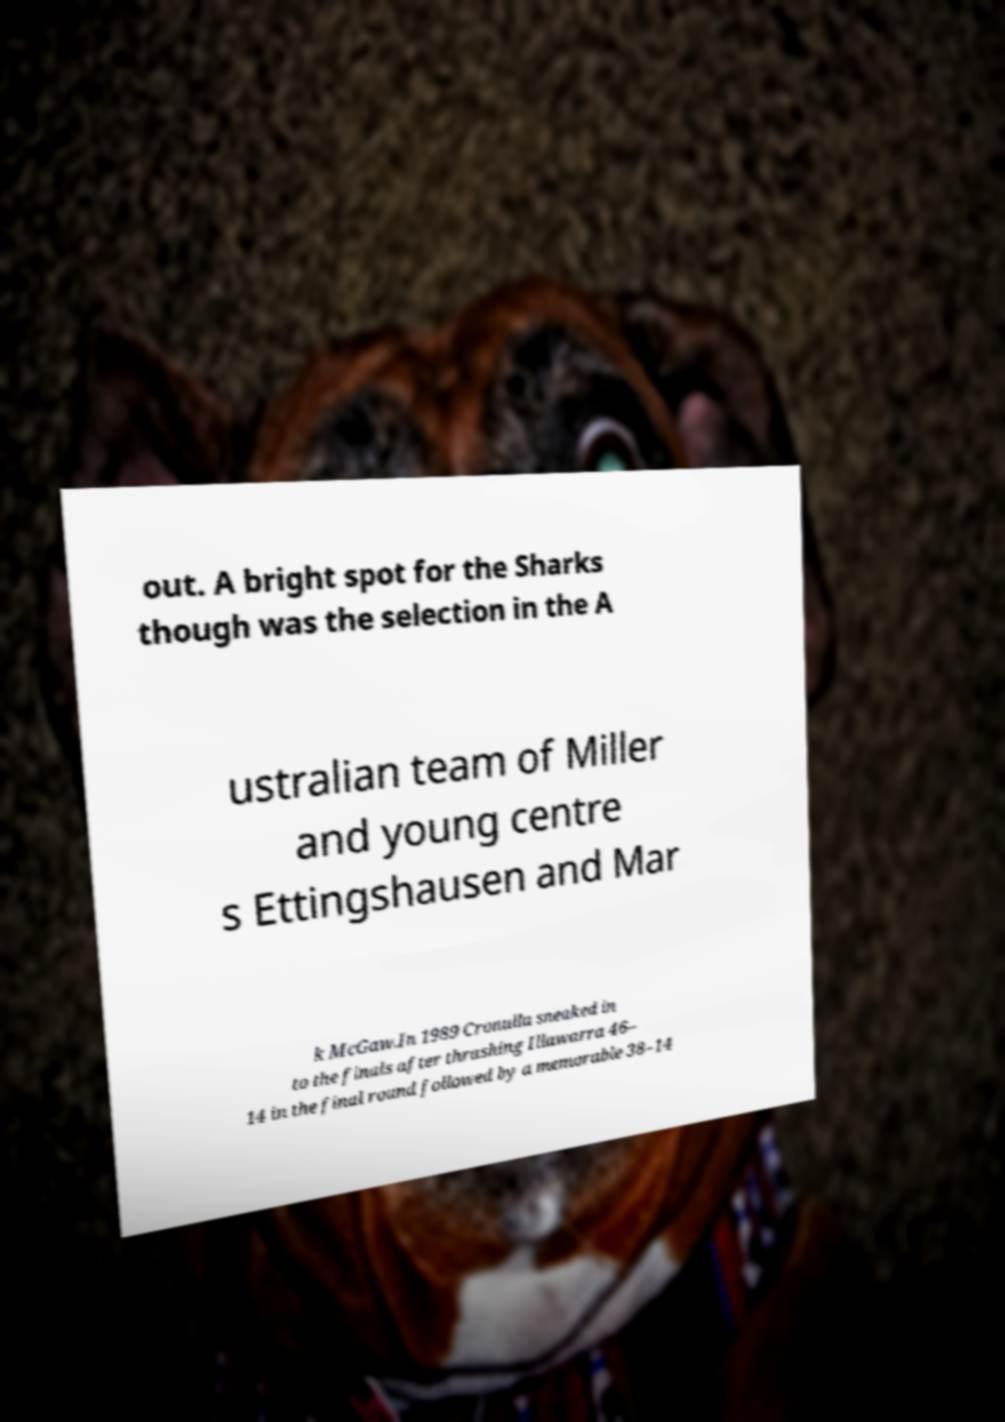Can you accurately transcribe the text from the provided image for me? out. A bright spot for the Sharks though was the selection in the A ustralian team of Miller and young centre s Ettingshausen and Mar k McGaw.In 1989 Cronulla sneaked in to the finals after thrashing Illawarra 46– 14 in the final round followed by a memorable 38–14 